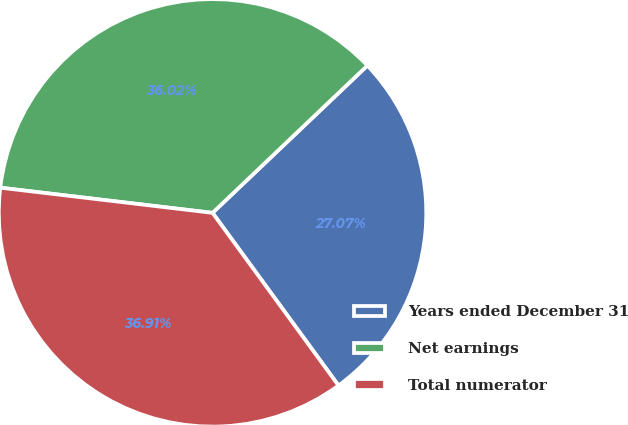<chart> <loc_0><loc_0><loc_500><loc_500><pie_chart><fcel>Years ended December 31<fcel>Net earnings<fcel>Total numerator<nl><fcel>27.07%<fcel>36.02%<fcel>36.91%<nl></chart> 